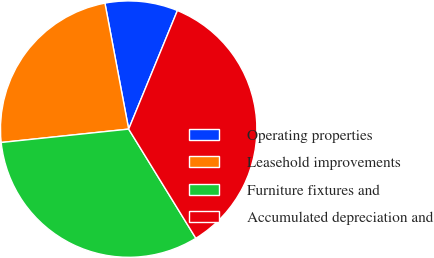<chart> <loc_0><loc_0><loc_500><loc_500><pie_chart><fcel>Operating properties<fcel>Leasehold improvements<fcel>Furniture fixtures and<fcel>Accumulated depreciation and<nl><fcel>9.17%<fcel>23.7%<fcel>32.11%<fcel>35.01%<nl></chart> 